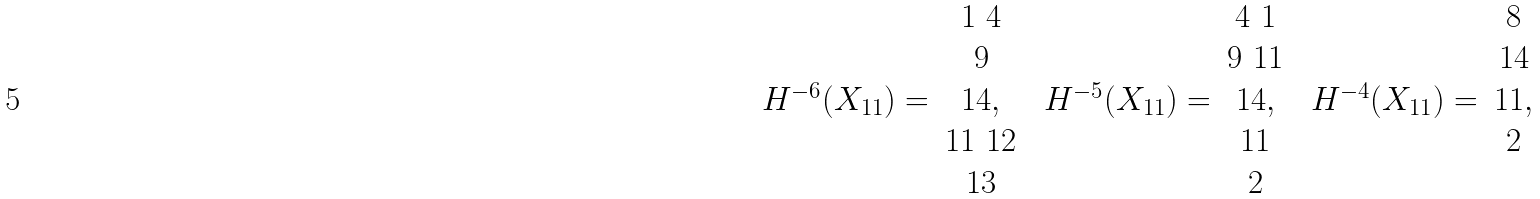<formula> <loc_0><loc_0><loc_500><loc_500>\begin{array} { c c } & 1 \ 4 \\ & 9 \\ H ^ { - 6 } ( X _ { 1 1 } ) = & 1 4 , \\ & 1 1 \ 1 2 \\ & 1 3 \\ \end{array} \ \begin{array} { c c } & 4 \ 1 \\ & 9 \ 1 1 \\ H ^ { - 5 } ( X _ { 1 1 } ) = & 1 4 , \\ & 1 1 \\ & 2 \\ \end{array} \ \begin{array} { c c } & 8 \\ & 1 4 \\ H ^ { - 4 } ( X _ { 1 1 } ) = & 1 1 , \\ & 2 \\ & \\ \end{array}</formula> 